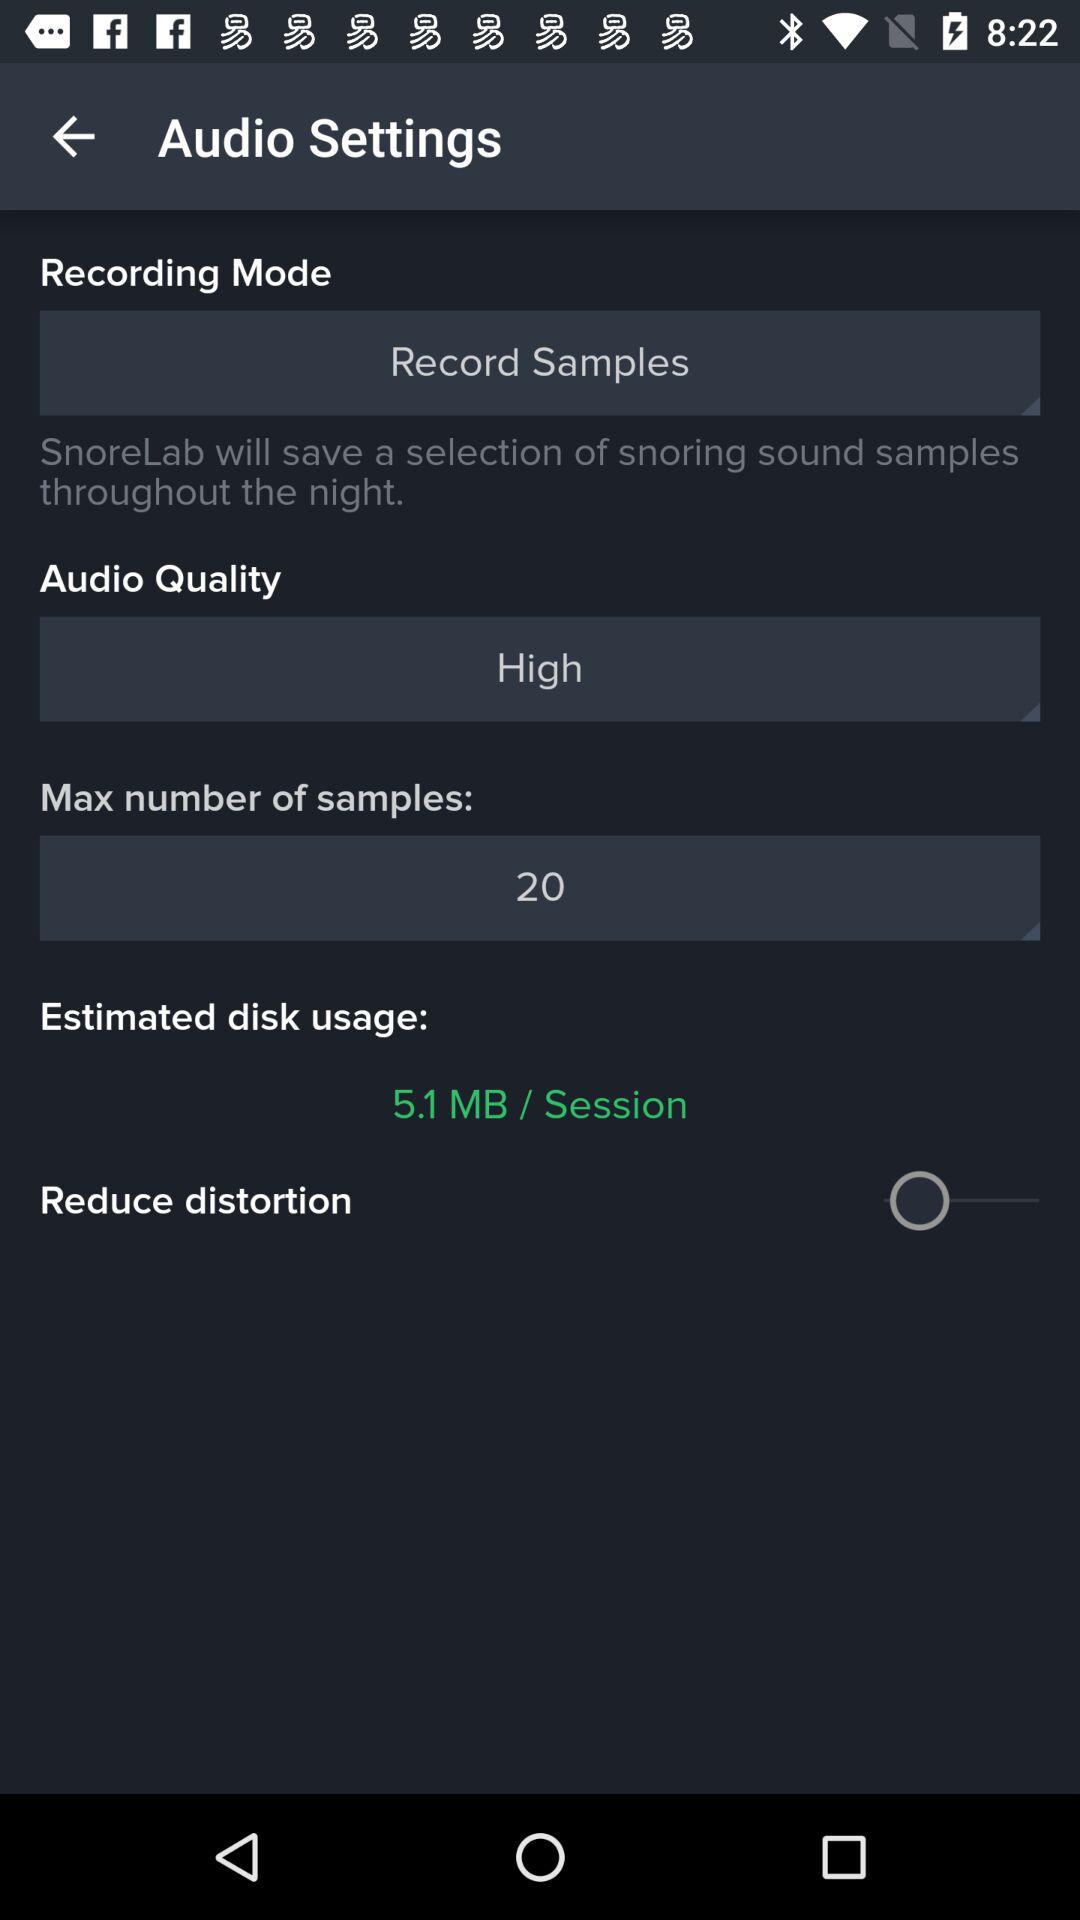What is the maximum number of samples? The maximum number of samples is 20. 